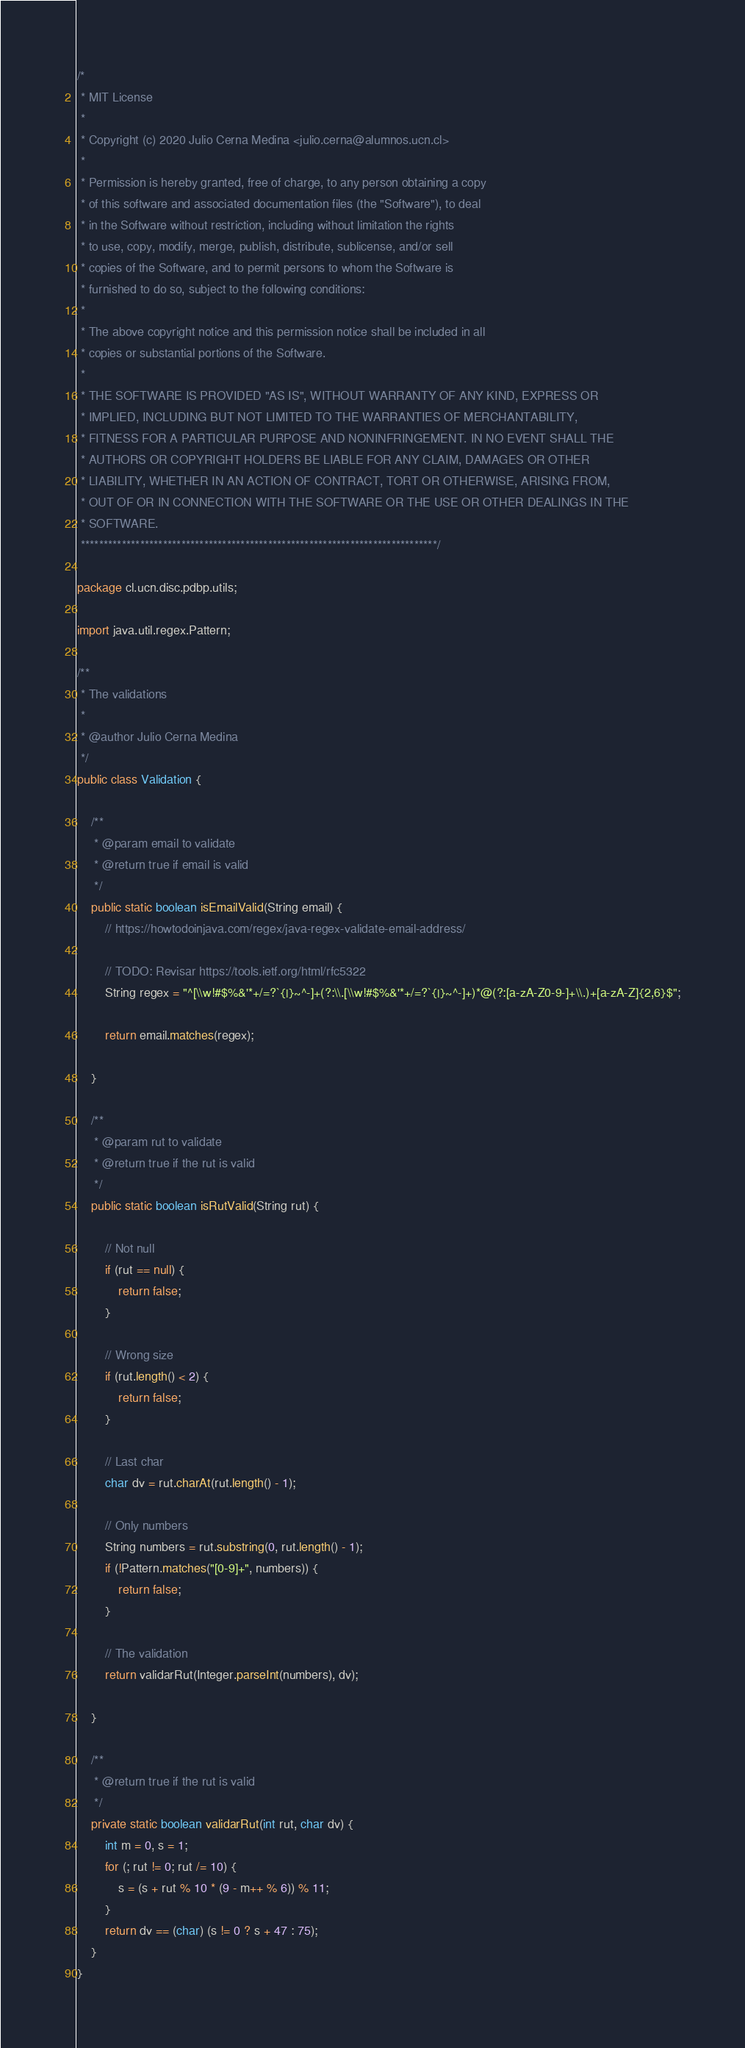Convert code to text. <code><loc_0><loc_0><loc_500><loc_500><_Java_>/*
 * MIT License
 *
 * Copyright (c) 2020 Julio Cerna Medina <julio.cerna@alumnos.ucn.cl>
 *
 * Permission is hereby granted, free of charge, to any person obtaining a copy
 * of this software and associated documentation files (the "Software"), to deal
 * in the Software without restriction, including without limitation the rights
 * to use, copy, modify, merge, publish, distribute, sublicense, and/or sell
 * copies of the Software, and to permit persons to whom the Software is
 * furnished to do so, subject to the following conditions:
 *
 * The above copyright notice and this permission notice shall be included in all
 * copies or substantial portions of the Software.
 *
 * THE SOFTWARE IS PROVIDED "AS IS", WITHOUT WARRANTY OF ANY KIND, EXPRESS OR
 * IMPLIED, INCLUDING BUT NOT LIMITED TO THE WARRANTIES OF MERCHANTABILITY,
 * FITNESS FOR A PARTICULAR PURPOSE AND NONINFRINGEMENT. IN NO EVENT SHALL THE
 * AUTHORS OR COPYRIGHT HOLDERS BE LIABLE FOR ANY CLAIM, DAMAGES OR OTHER
 * LIABILITY, WHETHER IN AN ACTION OF CONTRACT, TORT OR OTHERWISE, ARISING FROM,
 * OUT OF OR IN CONNECTION WITH THE SOFTWARE OR THE USE OR OTHER DEALINGS IN THE
 * SOFTWARE.
 ******************************************************************************/

package cl.ucn.disc.pdbp.utils;

import java.util.regex.Pattern;

/**
 * The validations
 *
 * @author Julio Cerna Medina
 */
public class Validation {

    /**
     * @param email to validate
     * @return true if email is valid
     */
    public static boolean isEmailValid(String email) {
        // https://howtodoinjava.com/regex/java-regex-validate-email-address/

        // TODO: Revisar https://tools.ietf.org/html/rfc5322
        String regex = "^[\\w!#$%&'*+/=?`{|}~^-]+(?:\\.[\\w!#$%&'*+/=?`{|}~^-]+)*@(?:[a-zA-Z0-9-]+\\.)+[a-zA-Z]{2,6}$";

        return email.matches(regex);

    }

    /**
     * @param rut to validate
     * @return true if the rut is valid
     */
    public static boolean isRutValid(String rut) {

        // Not null
        if (rut == null) {
            return false;
        }

        // Wrong size
        if (rut.length() < 2) {
            return false;
        }

        // Last char
        char dv = rut.charAt(rut.length() - 1);

        // Only numbers
        String numbers = rut.substring(0, rut.length() - 1);
        if (!Pattern.matches("[0-9]+", numbers)) {
            return false;
        }

        // The validation
        return validarRut(Integer.parseInt(numbers), dv);

    }

    /**
     * @return true if the rut is valid
     */
    private static boolean validarRut(int rut, char dv) {
        int m = 0, s = 1;
        for (; rut != 0; rut /= 10) {
            s = (s + rut % 10 * (9 - m++ % 6)) % 11;
        }
        return dv == (char) (s != 0 ? s + 47 : 75);
    }
}
</code> 